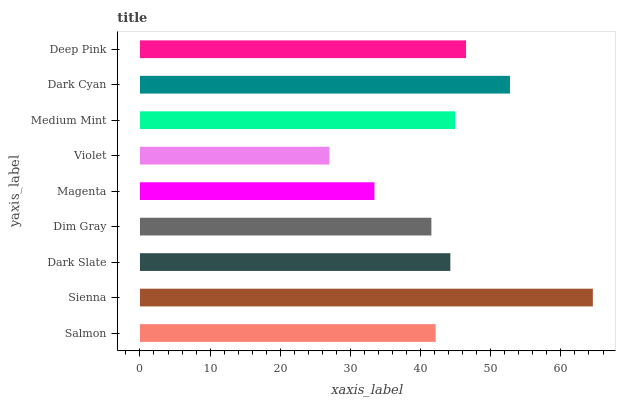Is Violet the minimum?
Answer yes or no. Yes. Is Sienna the maximum?
Answer yes or no. Yes. Is Dark Slate the minimum?
Answer yes or no. No. Is Dark Slate the maximum?
Answer yes or no. No. Is Sienna greater than Dark Slate?
Answer yes or no. Yes. Is Dark Slate less than Sienna?
Answer yes or no. Yes. Is Dark Slate greater than Sienna?
Answer yes or no. No. Is Sienna less than Dark Slate?
Answer yes or no. No. Is Dark Slate the high median?
Answer yes or no. Yes. Is Dark Slate the low median?
Answer yes or no. Yes. Is Dark Cyan the high median?
Answer yes or no. No. Is Magenta the low median?
Answer yes or no. No. 